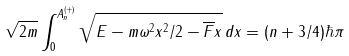<formula> <loc_0><loc_0><loc_500><loc_500>\sqrt { 2 m } \int _ { 0 } ^ { A ^ { ( + ) } _ { n } } \sqrt { E - m \omega ^ { 2 } x ^ { 2 } / 2 - \overline { F } x } \, d x = ( n + 3 / 4 ) \hbar { \pi }</formula> 